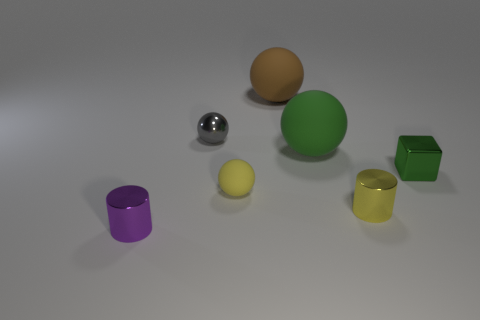There is a purple object that is in front of the shiny ball that is in front of the brown matte sphere; what is its material?
Your response must be concise. Metal. There is a brown ball that is the same size as the green sphere; what is its material?
Offer a terse response. Rubber. Are there any cyan blocks that have the same size as the green shiny thing?
Provide a succinct answer. No. There is a tiny cylinder behind the purple cylinder; what color is it?
Give a very brief answer. Yellow. There is a large thing that is on the right side of the big brown thing; are there any cylinders behind it?
Offer a terse response. No. What number of other objects are there of the same color as the shiny sphere?
Provide a short and direct response. 0. Is the size of the rubber thing that is in front of the small green cube the same as the shiny cylinder to the left of the large brown matte thing?
Ensure brevity in your answer.  Yes. There is a shiny thing that is in front of the cylinder behind the tiny purple metallic cylinder; how big is it?
Provide a short and direct response. Small. What material is the thing that is behind the small green metallic thing and right of the big brown rubber ball?
Provide a short and direct response. Rubber. The block has what color?
Your answer should be very brief. Green. 